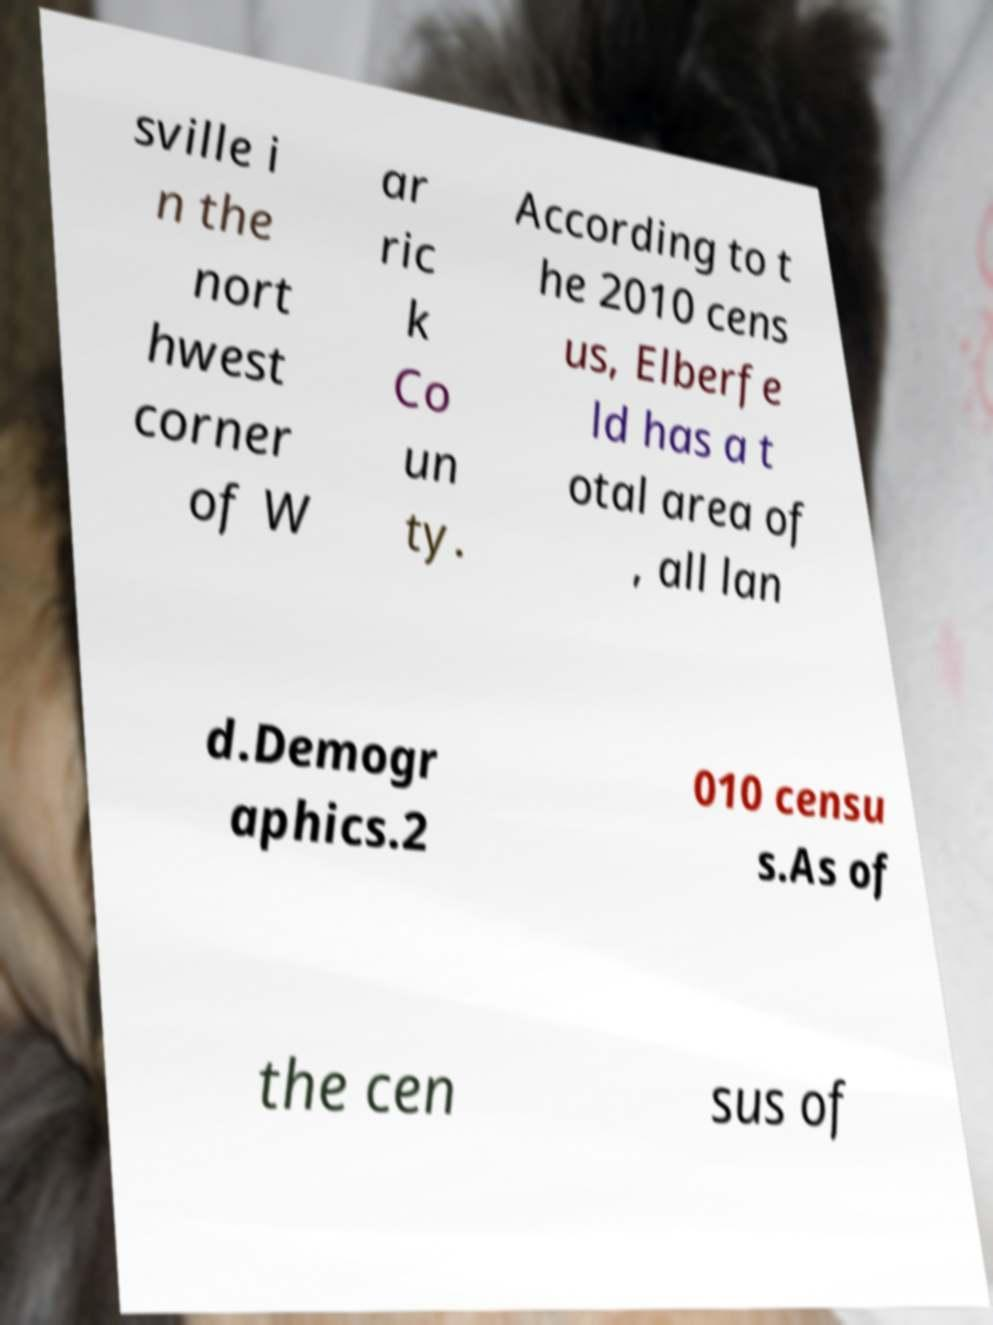Could you assist in decoding the text presented in this image and type it out clearly? sville i n the nort hwest corner of W ar ric k Co un ty. According to t he 2010 cens us, Elberfe ld has a t otal area of , all lan d.Demogr aphics.2 010 censu s.As of the cen sus of 